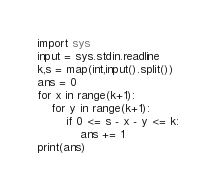Convert code to text. <code><loc_0><loc_0><loc_500><loc_500><_Python_>import sys
input = sys.stdin.readline
k,s = map(int,input().split())
ans = 0
for x in range(k+1):
    for y in range(k+1):
        if 0 <= s - x - y <= k:
            ans += 1
print(ans)
</code> 